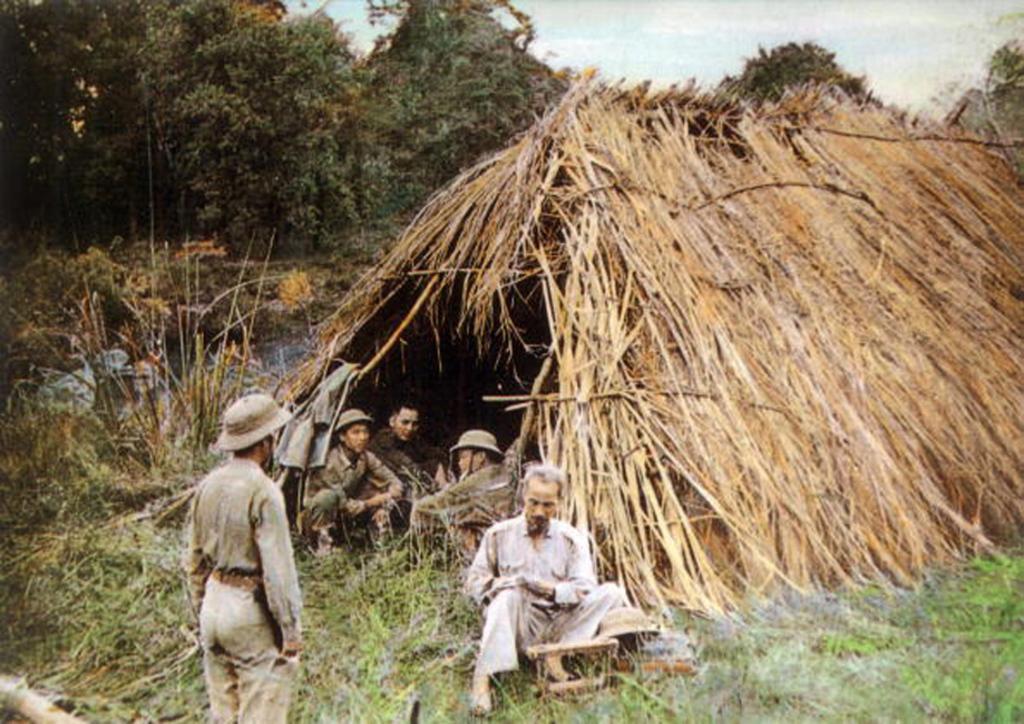Describe this image in one or two sentences. In the picture I can see people on the ground, a hut, the grass, plants, trees and some other objects. In the background I can see the sky. 